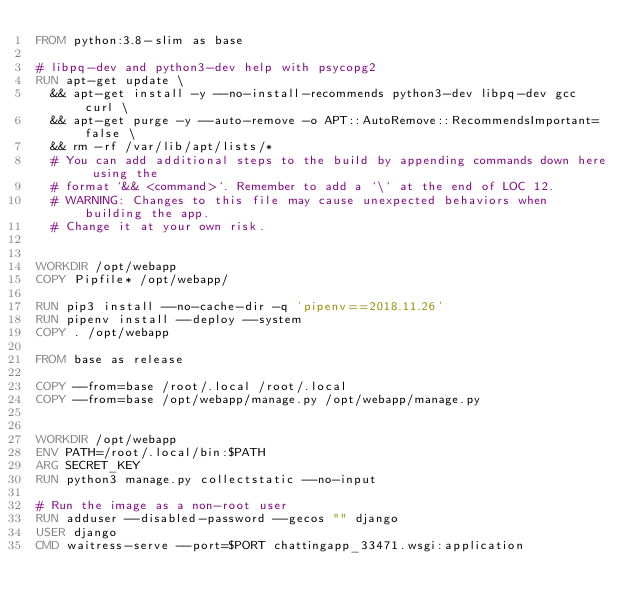Convert code to text. <code><loc_0><loc_0><loc_500><loc_500><_Dockerfile_>FROM python:3.8-slim as base

# libpq-dev and python3-dev help with psycopg2
RUN apt-get update \
  && apt-get install -y --no-install-recommends python3-dev libpq-dev gcc curl \
  && apt-get purge -y --auto-remove -o APT::AutoRemove::RecommendsImportant=false \
  && rm -rf /var/lib/apt/lists/*
  # You can add additional steps to the build by appending commands down here using the
  # format `&& <command>`. Remember to add a `\` at the end of LOC 12.
  # WARNING: Changes to this file may cause unexpected behaviors when building the app.
  # Change it at your own risk.


WORKDIR /opt/webapp
COPY Pipfile* /opt/webapp/

RUN pip3 install --no-cache-dir -q 'pipenv==2018.11.26' 
RUN pipenv install --deploy --system
COPY . /opt/webapp

FROM base as release

COPY --from=base /root/.local /root/.local
COPY --from=base /opt/webapp/manage.py /opt/webapp/manage.py


WORKDIR /opt/webapp
ENV PATH=/root/.local/bin:$PATH
ARG SECRET_KEY 
RUN python3 manage.py collectstatic --no-input

# Run the image as a non-root user
RUN adduser --disabled-password --gecos "" django
USER django
CMD waitress-serve --port=$PORT chattingapp_33471.wsgi:application
</code> 